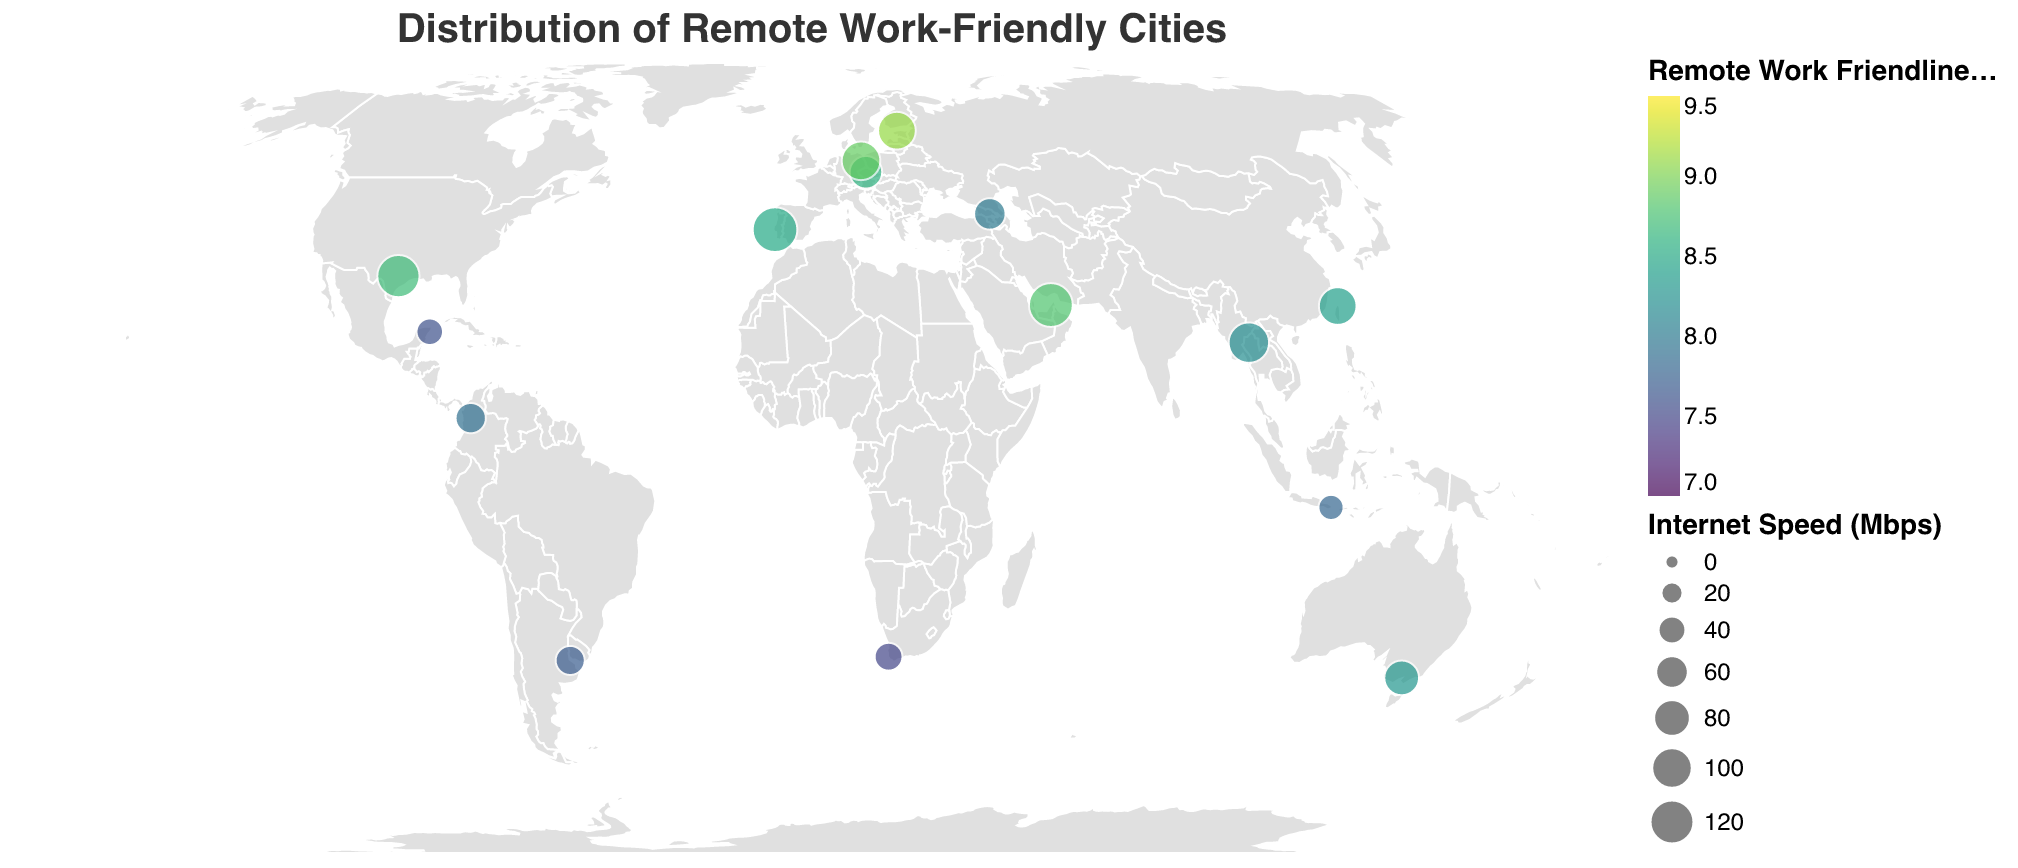What is the title of the figure? The title is displayed at the top center of the figure and reads "Distribution of Remote Work-Friendly Cities".
Answer: Distribution of Remote Work-Friendly Cities Which city has the highest "Remote Work Friendliness Score"? To find this, look for the data point with the highest score and match it to the corresponding city - the score is color-coded. The data point with the highest score has a score of 9.1.
Answer: Tallinn Which continent has the most cities that are remote work-friendly according to the plot? Count the number of unique cities marked on the plot per continent. Europe has the most, with four cities: Lisbon, Tallinn, Prague, and Berlin.
Answer: Europe What is the main feature symbolized by the size of the circles in the plot? The size of the circles represents Internet Speed (Mbps). Larger circles indicate higher internet speeds.
Answer: Internet Speed (Mbps) Compare the Remote Work Friendliness Score between Berlin and Medellin. Which is higher and by how much? Berlin has a score of 8.9, and Medellin has a score of 7.9. To find the difference, subtract Medellin's score from Berlin's score: 8.9 - 7.9 = 1.0.
Answer: Berlin by 1.0 Which city on the plot indicates having the highest number of co-working spaces? Look for the city with the highest number of co-working spaces in the tooltip information. Berlin has the highest number with 100 co-working spaces.
Answer: Berlin Among the cities listed, which offers Digital Nomad Visas and has the highest Internet Speed (Mbps)? Find cities that offer Digital Nomad Visas (marked 'Yes') and compare their internet speeds. Dubai, with 120 Mbps, offers the highest speed among such cities.
Answer: Dubai Which city in Asia has the lowest Remote Work Friendliness Score? Among Asian cities, compare the Remote Work Friendliness Scores from the tooltip information. Bali has the lowest score of 7.8.
Answer: Bali Between Austin and Melbourne, which city has more co-working spaces? Compare the number of co-working spaces between Austin and Melbourne from the tooltip information. Austin has 80 co-working spaces, while Melbourne has 60 co-working spaces.
Answer: Austin What is the average Internet Speed (Mbps) of the cities in North America? The cities in North America are Austin (110 Mbps) and Playa del Carmen (35 Mbps). Calculate the average: (110 + 35) / 2 = 72.5.
Answer: 72.5 